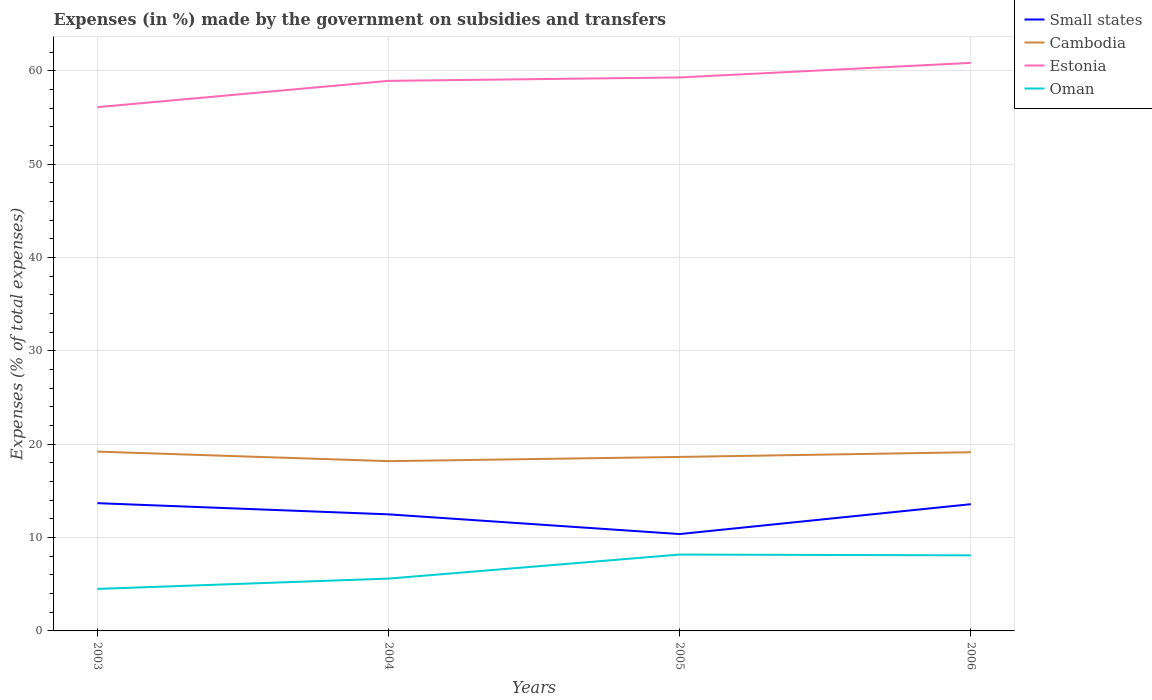Does the line corresponding to Estonia intersect with the line corresponding to Oman?
Keep it short and to the point. No. Is the number of lines equal to the number of legend labels?
Provide a succinct answer. Yes. Across all years, what is the maximum percentage of expenses made by the government on subsidies and transfers in Estonia?
Your answer should be compact. 56.13. In which year was the percentage of expenses made by the government on subsidies and transfers in Small states maximum?
Give a very brief answer. 2005. What is the total percentage of expenses made by the government on subsidies and transfers in Estonia in the graph?
Keep it short and to the point. -2.82. What is the difference between the highest and the second highest percentage of expenses made by the government on subsidies and transfers in Small states?
Give a very brief answer. 3.31. Is the percentage of expenses made by the government on subsidies and transfers in Cambodia strictly greater than the percentage of expenses made by the government on subsidies and transfers in Oman over the years?
Your answer should be very brief. No. What is the difference between two consecutive major ticks on the Y-axis?
Provide a succinct answer. 10. Does the graph contain grids?
Your response must be concise. Yes. Where does the legend appear in the graph?
Ensure brevity in your answer.  Top right. What is the title of the graph?
Your answer should be compact. Expenses (in %) made by the government on subsidies and transfers. What is the label or title of the X-axis?
Provide a short and direct response. Years. What is the label or title of the Y-axis?
Offer a very short reply. Expenses (% of total expenses). What is the Expenses (% of total expenses) in Small states in 2003?
Keep it short and to the point. 13.69. What is the Expenses (% of total expenses) of Cambodia in 2003?
Ensure brevity in your answer.  19.21. What is the Expenses (% of total expenses) in Estonia in 2003?
Your answer should be very brief. 56.13. What is the Expenses (% of total expenses) of Oman in 2003?
Offer a very short reply. 4.5. What is the Expenses (% of total expenses) in Small states in 2004?
Your answer should be very brief. 12.49. What is the Expenses (% of total expenses) in Cambodia in 2004?
Ensure brevity in your answer.  18.19. What is the Expenses (% of total expenses) in Estonia in 2004?
Offer a very short reply. 58.94. What is the Expenses (% of total expenses) of Oman in 2004?
Keep it short and to the point. 5.61. What is the Expenses (% of total expenses) of Small states in 2005?
Your answer should be compact. 10.38. What is the Expenses (% of total expenses) of Cambodia in 2005?
Provide a succinct answer. 18.64. What is the Expenses (% of total expenses) of Estonia in 2005?
Your answer should be compact. 59.31. What is the Expenses (% of total expenses) of Oman in 2005?
Provide a succinct answer. 8.18. What is the Expenses (% of total expenses) in Small states in 2006?
Offer a very short reply. 13.58. What is the Expenses (% of total expenses) of Cambodia in 2006?
Provide a short and direct response. 19.15. What is the Expenses (% of total expenses) of Estonia in 2006?
Make the answer very short. 60.87. What is the Expenses (% of total expenses) in Oman in 2006?
Offer a very short reply. 8.1. Across all years, what is the maximum Expenses (% of total expenses) of Small states?
Make the answer very short. 13.69. Across all years, what is the maximum Expenses (% of total expenses) of Cambodia?
Your response must be concise. 19.21. Across all years, what is the maximum Expenses (% of total expenses) of Estonia?
Your answer should be compact. 60.87. Across all years, what is the maximum Expenses (% of total expenses) in Oman?
Your answer should be very brief. 8.18. Across all years, what is the minimum Expenses (% of total expenses) of Small states?
Your response must be concise. 10.38. Across all years, what is the minimum Expenses (% of total expenses) in Cambodia?
Your response must be concise. 18.19. Across all years, what is the minimum Expenses (% of total expenses) in Estonia?
Ensure brevity in your answer.  56.13. Across all years, what is the minimum Expenses (% of total expenses) of Oman?
Offer a terse response. 4.5. What is the total Expenses (% of total expenses) of Small states in the graph?
Give a very brief answer. 50.14. What is the total Expenses (% of total expenses) of Cambodia in the graph?
Provide a short and direct response. 75.2. What is the total Expenses (% of total expenses) of Estonia in the graph?
Provide a succinct answer. 235.25. What is the total Expenses (% of total expenses) of Oman in the graph?
Provide a short and direct response. 26.39. What is the difference between the Expenses (% of total expenses) in Small states in 2003 and that in 2004?
Keep it short and to the point. 1.2. What is the difference between the Expenses (% of total expenses) of Cambodia in 2003 and that in 2004?
Offer a terse response. 1.02. What is the difference between the Expenses (% of total expenses) of Estonia in 2003 and that in 2004?
Offer a terse response. -2.82. What is the difference between the Expenses (% of total expenses) of Oman in 2003 and that in 2004?
Offer a terse response. -1.1. What is the difference between the Expenses (% of total expenses) in Small states in 2003 and that in 2005?
Offer a very short reply. 3.31. What is the difference between the Expenses (% of total expenses) in Cambodia in 2003 and that in 2005?
Provide a short and direct response. 0.57. What is the difference between the Expenses (% of total expenses) of Estonia in 2003 and that in 2005?
Make the answer very short. -3.18. What is the difference between the Expenses (% of total expenses) of Oman in 2003 and that in 2005?
Ensure brevity in your answer.  -3.68. What is the difference between the Expenses (% of total expenses) in Small states in 2003 and that in 2006?
Offer a very short reply. 0.11. What is the difference between the Expenses (% of total expenses) in Cambodia in 2003 and that in 2006?
Ensure brevity in your answer.  0.07. What is the difference between the Expenses (% of total expenses) of Estonia in 2003 and that in 2006?
Offer a terse response. -4.74. What is the difference between the Expenses (% of total expenses) in Oman in 2003 and that in 2006?
Make the answer very short. -3.6. What is the difference between the Expenses (% of total expenses) of Small states in 2004 and that in 2005?
Offer a terse response. 2.11. What is the difference between the Expenses (% of total expenses) in Cambodia in 2004 and that in 2005?
Offer a very short reply. -0.45. What is the difference between the Expenses (% of total expenses) in Estonia in 2004 and that in 2005?
Keep it short and to the point. -0.37. What is the difference between the Expenses (% of total expenses) in Oman in 2004 and that in 2005?
Provide a succinct answer. -2.58. What is the difference between the Expenses (% of total expenses) in Small states in 2004 and that in 2006?
Your answer should be compact. -1.09. What is the difference between the Expenses (% of total expenses) of Cambodia in 2004 and that in 2006?
Keep it short and to the point. -0.96. What is the difference between the Expenses (% of total expenses) in Estonia in 2004 and that in 2006?
Your answer should be compact. -1.93. What is the difference between the Expenses (% of total expenses) of Oman in 2004 and that in 2006?
Offer a terse response. -2.49. What is the difference between the Expenses (% of total expenses) in Cambodia in 2005 and that in 2006?
Your answer should be compact. -0.5. What is the difference between the Expenses (% of total expenses) of Estonia in 2005 and that in 2006?
Your answer should be very brief. -1.56. What is the difference between the Expenses (% of total expenses) of Oman in 2005 and that in 2006?
Make the answer very short. 0.08. What is the difference between the Expenses (% of total expenses) of Small states in 2003 and the Expenses (% of total expenses) of Cambodia in 2004?
Your answer should be compact. -4.5. What is the difference between the Expenses (% of total expenses) of Small states in 2003 and the Expenses (% of total expenses) of Estonia in 2004?
Your answer should be very brief. -45.25. What is the difference between the Expenses (% of total expenses) of Small states in 2003 and the Expenses (% of total expenses) of Oman in 2004?
Give a very brief answer. 8.08. What is the difference between the Expenses (% of total expenses) in Cambodia in 2003 and the Expenses (% of total expenses) in Estonia in 2004?
Give a very brief answer. -39.73. What is the difference between the Expenses (% of total expenses) of Cambodia in 2003 and the Expenses (% of total expenses) of Oman in 2004?
Provide a succinct answer. 13.61. What is the difference between the Expenses (% of total expenses) in Estonia in 2003 and the Expenses (% of total expenses) in Oman in 2004?
Provide a short and direct response. 50.52. What is the difference between the Expenses (% of total expenses) of Small states in 2003 and the Expenses (% of total expenses) of Cambodia in 2005?
Keep it short and to the point. -4.95. What is the difference between the Expenses (% of total expenses) of Small states in 2003 and the Expenses (% of total expenses) of Estonia in 2005?
Give a very brief answer. -45.62. What is the difference between the Expenses (% of total expenses) of Small states in 2003 and the Expenses (% of total expenses) of Oman in 2005?
Offer a terse response. 5.51. What is the difference between the Expenses (% of total expenses) of Cambodia in 2003 and the Expenses (% of total expenses) of Estonia in 2005?
Keep it short and to the point. -40.09. What is the difference between the Expenses (% of total expenses) of Cambodia in 2003 and the Expenses (% of total expenses) of Oman in 2005?
Make the answer very short. 11.03. What is the difference between the Expenses (% of total expenses) in Estonia in 2003 and the Expenses (% of total expenses) in Oman in 2005?
Provide a succinct answer. 47.94. What is the difference between the Expenses (% of total expenses) in Small states in 2003 and the Expenses (% of total expenses) in Cambodia in 2006?
Give a very brief answer. -5.46. What is the difference between the Expenses (% of total expenses) in Small states in 2003 and the Expenses (% of total expenses) in Estonia in 2006?
Provide a succinct answer. -47.18. What is the difference between the Expenses (% of total expenses) of Small states in 2003 and the Expenses (% of total expenses) of Oman in 2006?
Give a very brief answer. 5.59. What is the difference between the Expenses (% of total expenses) in Cambodia in 2003 and the Expenses (% of total expenses) in Estonia in 2006?
Offer a terse response. -41.66. What is the difference between the Expenses (% of total expenses) in Cambodia in 2003 and the Expenses (% of total expenses) in Oman in 2006?
Provide a short and direct response. 11.12. What is the difference between the Expenses (% of total expenses) in Estonia in 2003 and the Expenses (% of total expenses) in Oman in 2006?
Keep it short and to the point. 48.03. What is the difference between the Expenses (% of total expenses) in Small states in 2004 and the Expenses (% of total expenses) in Cambodia in 2005?
Ensure brevity in your answer.  -6.15. What is the difference between the Expenses (% of total expenses) of Small states in 2004 and the Expenses (% of total expenses) of Estonia in 2005?
Give a very brief answer. -46.82. What is the difference between the Expenses (% of total expenses) of Small states in 2004 and the Expenses (% of total expenses) of Oman in 2005?
Your answer should be compact. 4.31. What is the difference between the Expenses (% of total expenses) of Cambodia in 2004 and the Expenses (% of total expenses) of Estonia in 2005?
Make the answer very short. -41.12. What is the difference between the Expenses (% of total expenses) in Cambodia in 2004 and the Expenses (% of total expenses) in Oman in 2005?
Ensure brevity in your answer.  10.01. What is the difference between the Expenses (% of total expenses) of Estonia in 2004 and the Expenses (% of total expenses) of Oman in 2005?
Provide a short and direct response. 50.76. What is the difference between the Expenses (% of total expenses) of Small states in 2004 and the Expenses (% of total expenses) of Cambodia in 2006?
Offer a terse response. -6.66. What is the difference between the Expenses (% of total expenses) of Small states in 2004 and the Expenses (% of total expenses) of Estonia in 2006?
Keep it short and to the point. -48.38. What is the difference between the Expenses (% of total expenses) of Small states in 2004 and the Expenses (% of total expenses) of Oman in 2006?
Your answer should be compact. 4.39. What is the difference between the Expenses (% of total expenses) of Cambodia in 2004 and the Expenses (% of total expenses) of Estonia in 2006?
Make the answer very short. -42.68. What is the difference between the Expenses (% of total expenses) in Cambodia in 2004 and the Expenses (% of total expenses) in Oman in 2006?
Ensure brevity in your answer.  10.09. What is the difference between the Expenses (% of total expenses) in Estonia in 2004 and the Expenses (% of total expenses) in Oman in 2006?
Your response must be concise. 50.84. What is the difference between the Expenses (% of total expenses) in Small states in 2005 and the Expenses (% of total expenses) in Cambodia in 2006?
Make the answer very short. -8.77. What is the difference between the Expenses (% of total expenses) of Small states in 2005 and the Expenses (% of total expenses) of Estonia in 2006?
Keep it short and to the point. -50.49. What is the difference between the Expenses (% of total expenses) in Small states in 2005 and the Expenses (% of total expenses) in Oman in 2006?
Your answer should be compact. 2.28. What is the difference between the Expenses (% of total expenses) in Cambodia in 2005 and the Expenses (% of total expenses) in Estonia in 2006?
Keep it short and to the point. -42.23. What is the difference between the Expenses (% of total expenses) of Cambodia in 2005 and the Expenses (% of total expenses) of Oman in 2006?
Your response must be concise. 10.55. What is the difference between the Expenses (% of total expenses) of Estonia in 2005 and the Expenses (% of total expenses) of Oman in 2006?
Provide a succinct answer. 51.21. What is the average Expenses (% of total expenses) in Small states per year?
Provide a succinct answer. 12.54. What is the average Expenses (% of total expenses) of Cambodia per year?
Give a very brief answer. 18.8. What is the average Expenses (% of total expenses) of Estonia per year?
Your response must be concise. 58.81. What is the average Expenses (% of total expenses) in Oman per year?
Offer a very short reply. 6.6. In the year 2003, what is the difference between the Expenses (% of total expenses) in Small states and Expenses (% of total expenses) in Cambodia?
Provide a short and direct response. -5.52. In the year 2003, what is the difference between the Expenses (% of total expenses) in Small states and Expenses (% of total expenses) in Estonia?
Give a very brief answer. -42.44. In the year 2003, what is the difference between the Expenses (% of total expenses) in Small states and Expenses (% of total expenses) in Oman?
Provide a short and direct response. 9.19. In the year 2003, what is the difference between the Expenses (% of total expenses) of Cambodia and Expenses (% of total expenses) of Estonia?
Your answer should be compact. -36.91. In the year 2003, what is the difference between the Expenses (% of total expenses) in Cambodia and Expenses (% of total expenses) in Oman?
Keep it short and to the point. 14.71. In the year 2003, what is the difference between the Expenses (% of total expenses) of Estonia and Expenses (% of total expenses) of Oman?
Provide a succinct answer. 51.62. In the year 2004, what is the difference between the Expenses (% of total expenses) of Small states and Expenses (% of total expenses) of Cambodia?
Make the answer very short. -5.7. In the year 2004, what is the difference between the Expenses (% of total expenses) in Small states and Expenses (% of total expenses) in Estonia?
Your answer should be very brief. -46.45. In the year 2004, what is the difference between the Expenses (% of total expenses) of Small states and Expenses (% of total expenses) of Oman?
Make the answer very short. 6.88. In the year 2004, what is the difference between the Expenses (% of total expenses) in Cambodia and Expenses (% of total expenses) in Estonia?
Ensure brevity in your answer.  -40.75. In the year 2004, what is the difference between the Expenses (% of total expenses) in Cambodia and Expenses (% of total expenses) in Oman?
Keep it short and to the point. 12.59. In the year 2004, what is the difference between the Expenses (% of total expenses) in Estonia and Expenses (% of total expenses) in Oman?
Keep it short and to the point. 53.34. In the year 2005, what is the difference between the Expenses (% of total expenses) of Small states and Expenses (% of total expenses) of Cambodia?
Ensure brevity in your answer.  -8.26. In the year 2005, what is the difference between the Expenses (% of total expenses) of Small states and Expenses (% of total expenses) of Estonia?
Make the answer very short. -48.93. In the year 2005, what is the difference between the Expenses (% of total expenses) in Small states and Expenses (% of total expenses) in Oman?
Your answer should be very brief. 2.2. In the year 2005, what is the difference between the Expenses (% of total expenses) of Cambodia and Expenses (% of total expenses) of Estonia?
Offer a terse response. -40.66. In the year 2005, what is the difference between the Expenses (% of total expenses) in Cambodia and Expenses (% of total expenses) in Oman?
Your answer should be very brief. 10.46. In the year 2005, what is the difference between the Expenses (% of total expenses) in Estonia and Expenses (% of total expenses) in Oman?
Give a very brief answer. 51.13. In the year 2006, what is the difference between the Expenses (% of total expenses) of Small states and Expenses (% of total expenses) of Cambodia?
Provide a short and direct response. -5.57. In the year 2006, what is the difference between the Expenses (% of total expenses) of Small states and Expenses (% of total expenses) of Estonia?
Your response must be concise. -47.29. In the year 2006, what is the difference between the Expenses (% of total expenses) of Small states and Expenses (% of total expenses) of Oman?
Your response must be concise. 5.48. In the year 2006, what is the difference between the Expenses (% of total expenses) of Cambodia and Expenses (% of total expenses) of Estonia?
Make the answer very short. -41.72. In the year 2006, what is the difference between the Expenses (% of total expenses) of Cambodia and Expenses (% of total expenses) of Oman?
Ensure brevity in your answer.  11.05. In the year 2006, what is the difference between the Expenses (% of total expenses) in Estonia and Expenses (% of total expenses) in Oman?
Your response must be concise. 52.77. What is the ratio of the Expenses (% of total expenses) in Small states in 2003 to that in 2004?
Provide a short and direct response. 1.1. What is the ratio of the Expenses (% of total expenses) in Cambodia in 2003 to that in 2004?
Provide a succinct answer. 1.06. What is the ratio of the Expenses (% of total expenses) of Estonia in 2003 to that in 2004?
Make the answer very short. 0.95. What is the ratio of the Expenses (% of total expenses) in Oman in 2003 to that in 2004?
Make the answer very short. 0.8. What is the ratio of the Expenses (% of total expenses) in Small states in 2003 to that in 2005?
Your answer should be compact. 1.32. What is the ratio of the Expenses (% of total expenses) in Cambodia in 2003 to that in 2005?
Provide a succinct answer. 1.03. What is the ratio of the Expenses (% of total expenses) in Estonia in 2003 to that in 2005?
Provide a succinct answer. 0.95. What is the ratio of the Expenses (% of total expenses) in Oman in 2003 to that in 2005?
Keep it short and to the point. 0.55. What is the ratio of the Expenses (% of total expenses) of Small states in 2003 to that in 2006?
Provide a succinct answer. 1.01. What is the ratio of the Expenses (% of total expenses) of Estonia in 2003 to that in 2006?
Provide a short and direct response. 0.92. What is the ratio of the Expenses (% of total expenses) of Oman in 2003 to that in 2006?
Ensure brevity in your answer.  0.56. What is the ratio of the Expenses (% of total expenses) in Small states in 2004 to that in 2005?
Offer a terse response. 1.2. What is the ratio of the Expenses (% of total expenses) of Cambodia in 2004 to that in 2005?
Provide a short and direct response. 0.98. What is the ratio of the Expenses (% of total expenses) of Estonia in 2004 to that in 2005?
Make the answer very short. 0.99. What is the ratio of the Expenses (% of total expenses) of Oman in 2004 to that in 2005?
Offer a very short reply. 0.69. What is the ratio of the Expenses (% of total expenses) of Small states in 2004 to that in 2006?
Ensure brevity in your answer.  0.92. What is the ratio of the Expenses (% of total expenses) in Cambodia in 2004 to that in 2006?
Make the answer very short. 0.95. What is the ratio of the Expenses (% of total expenses) in Estonia in 2004 to that in 2006?
Keep it short and to the point. 0.97. What is the ratio of the Expenses (% of total expenses) of Oman in 2004 to that in 2006?
Your response must be concise. 0.69. What is the ratio of the Expenses (% of total expenses) of Small states in 2005 to that in 2006?
Give a very brief answer. 0.76. What is the ratio of the Expenses (% of total expenses) of Cambodia in 2005 to that in 2006?
Your response must be concise. 0.97. What is the ratio of the Expenses (% of total expenses) in Estonia in 2005 to that in 2006?
Provide a short and direct response. 0.97. What is the ratio of the Expenses (% of total expenses) of Oman in 2005 to that in 2006?
Provide a succinct answer. 1.01. What is the difference between the highest and the second highest Expenses (% of total expenses) in Small states?
Provide a succinct answer. 0.11. What is the difference between the highest and the second highest Expenses (% of total expenses) in Cambodia?
Offer a very short reply. 0.07. What is the difference between the highest and the second highest Expenses (% of total expenses) in Estonia?
Offer a terse response. 1.56. What is the difference between the highest and the second highest Expenses (% of total expenses) in Oman?
Provide a succinct answer. 0.08. What is the difference between the highest and the lowest Expenses (% of total expenses) in Small states?
Keep it short and to the point. 3.31. What is the difference between the highest and the lowest Expenses (% of total expenses) of Cambodia?
Give a very brief answer. 1.02. What is the difference between the highest and the lowest Expenses (% of total expenses) in Estonia?
Make the answer very short. 4.74. What is the difference between the highest and the lowest Expenses (% of total expenses) in Oman?
Your answer should be compact. 3.68. 